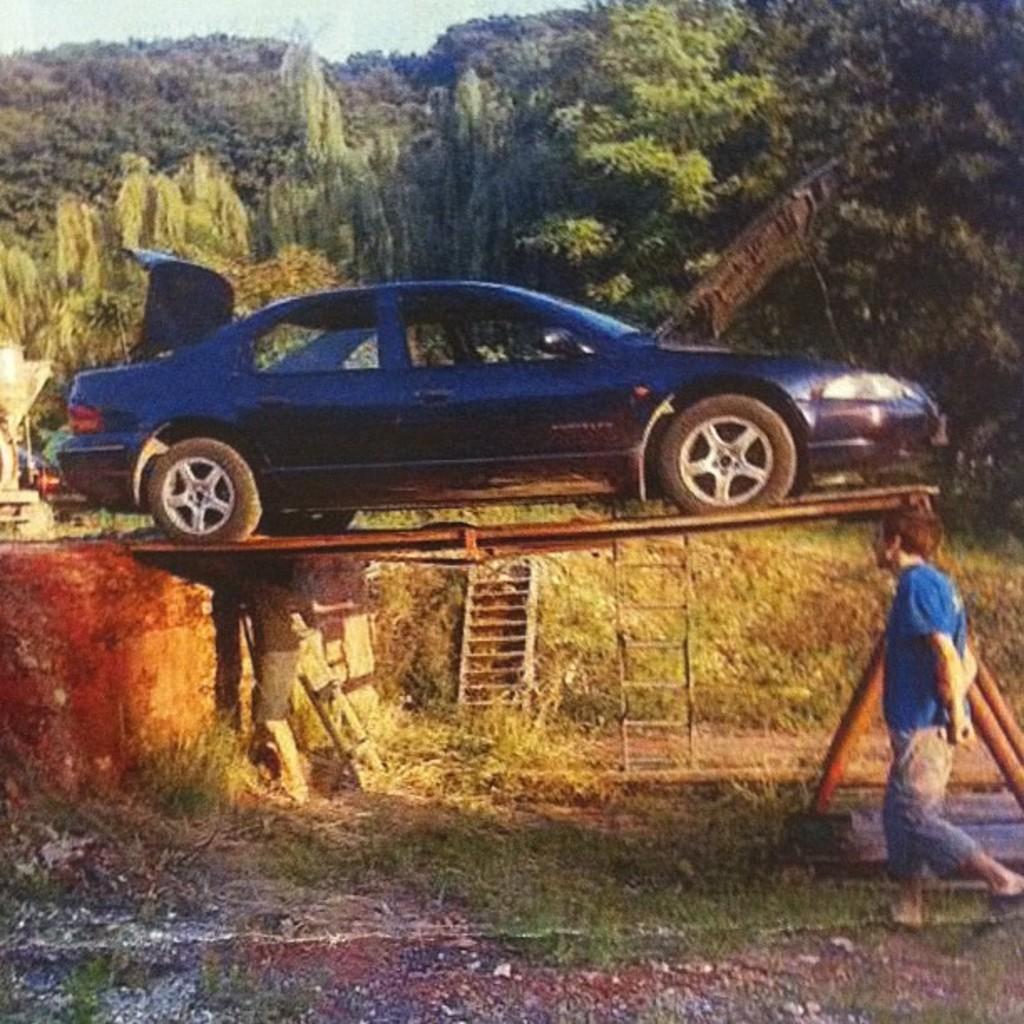In one or two sentences, can you explain what this image depicts? It is a car in the middle of an image. In the right side a man is walking he wore a blue color t-shirt. In the back side there are trees. 